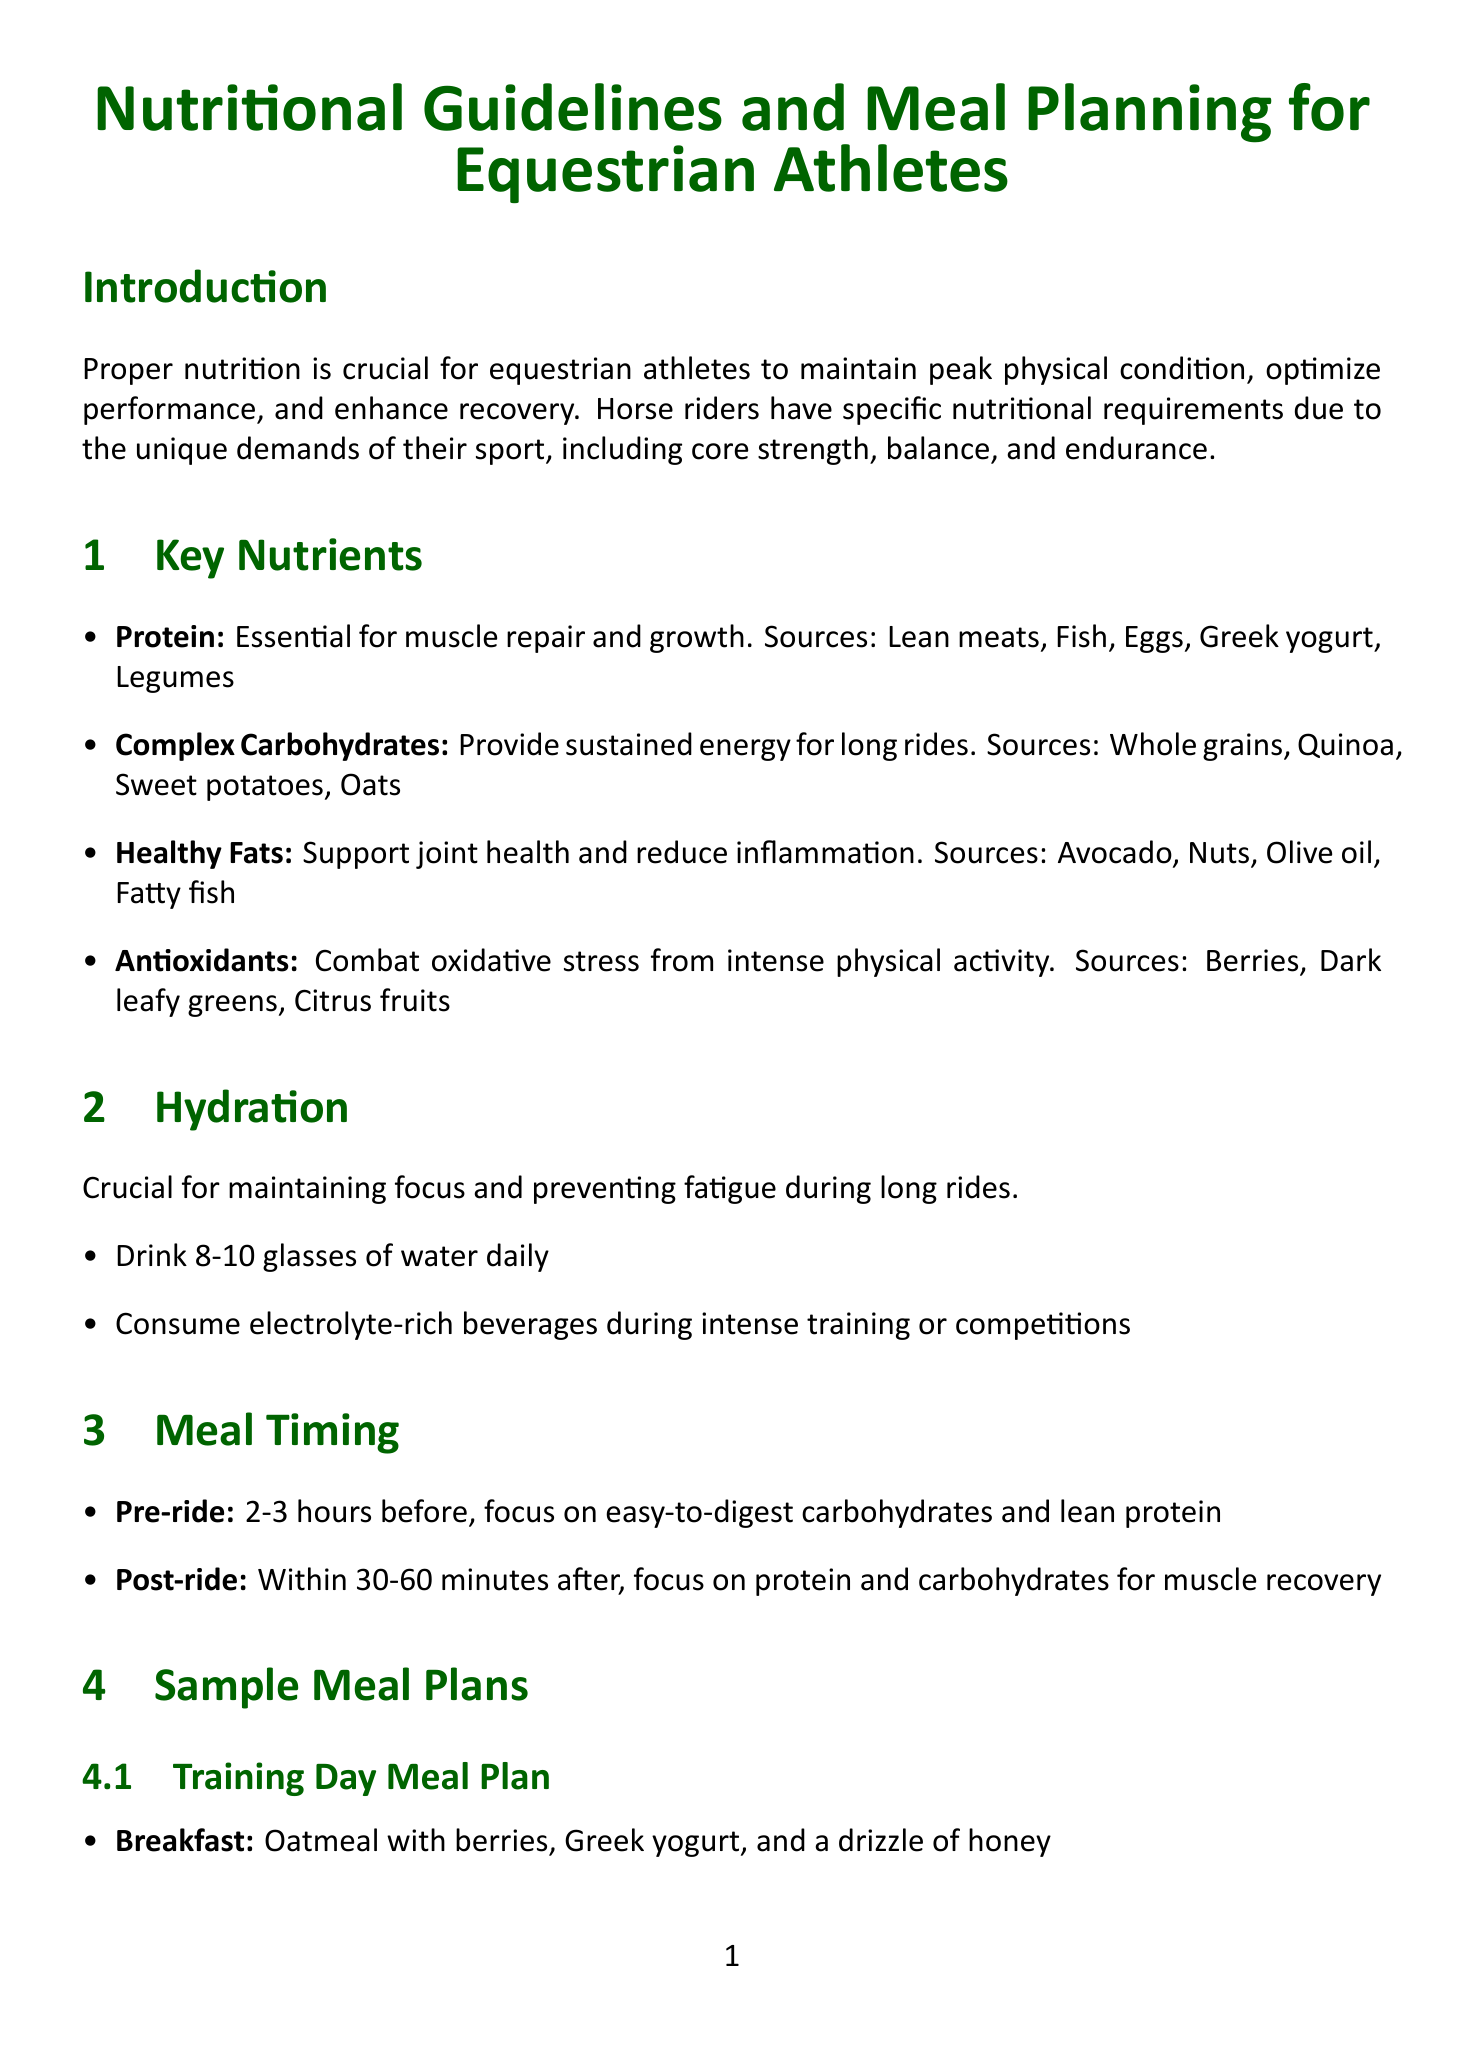What is the title of the document? The title appears prominently at the top of the document, introducing the subject matter.
Answer: Nutritional Guidelines and Meal Planning for Equestrian Athletes Which nutrient is essential for muscle repair and growth? The document lists key nutrients and their importance, specifically highlighting one nutrient that supports muscle health.
Answer: Protein What time should a pre-ride meal be consumed? The meal timing section specifies when pre-ride meals should be taken to optimize performance.
Answer: 2-3 hours before What is recommended for hydration during intense training? The hydration guidelines outline a specific type of beverage to consume during high-intensity activities.
Answer: Electrolyte-rich beverages How many grams of Omega-3 fatty acids is recommended daily? The supplements section details the recommended intake amounts for specific supplements beneficial to equestrian athletes.
Answer: 1-2 grams daily What type of carbohydrates should be focused on for pre-ride meals? The meal timing section emphasizes the kind of carbohydrates that are easy to digest for pre-ride nutrition.
Answer: Easy-to-digest carbohydrates What is a recovery snack suggested after training? The sample meal plans include a specific snack designed for recovery after physical activity.
Answer: Protein smoothie with whey protein, spinach, and frozen mixed berries Which recipe includes quinoa as an ingredient? The recipes section lists dishes, one of which features quinoa prominently in its nutritional profile.
Answer: Rider's Power Bowl 